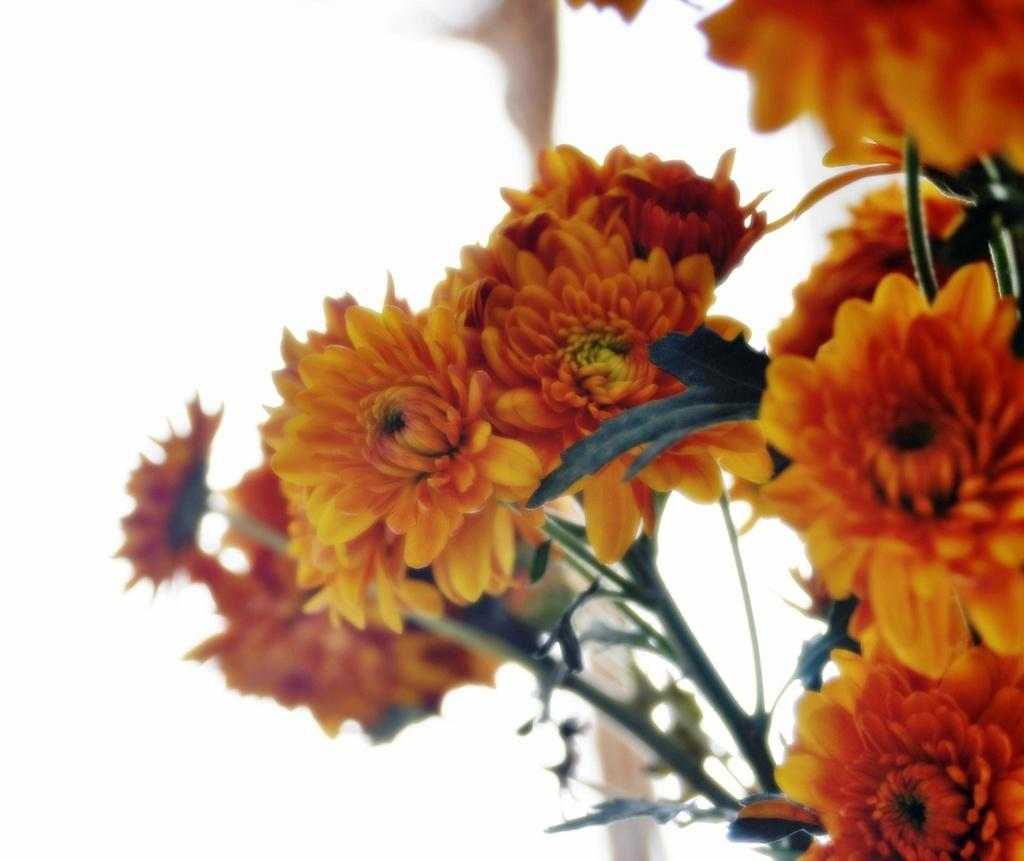What type of living organisms can be seen in the image? There are flowers in the image. What color is the background of the image? The background of the image is white. What type of root can be seen growing from the flowers in the image? There is no root visible in the image, as it only shows the flowers and not their underground parts. 